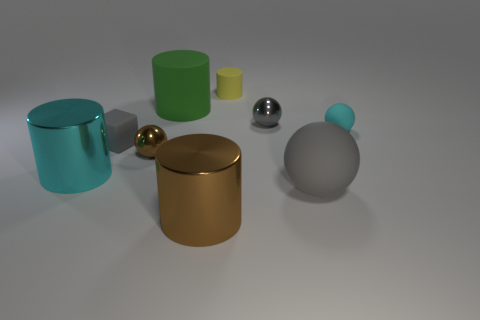How do the shadows cast by the objects inform us about the light source? The shadows are soft and extend to the right of the objects, indicating that the light source is off to the left. The shadows help discern the direction and diffuseness of the light.  Are there any indicators about the size of the objects? There are no direct indicators of size, such as a reference object, but the relative sizes and shadows can provide clues to their approximate dimensions in relation to each other. 